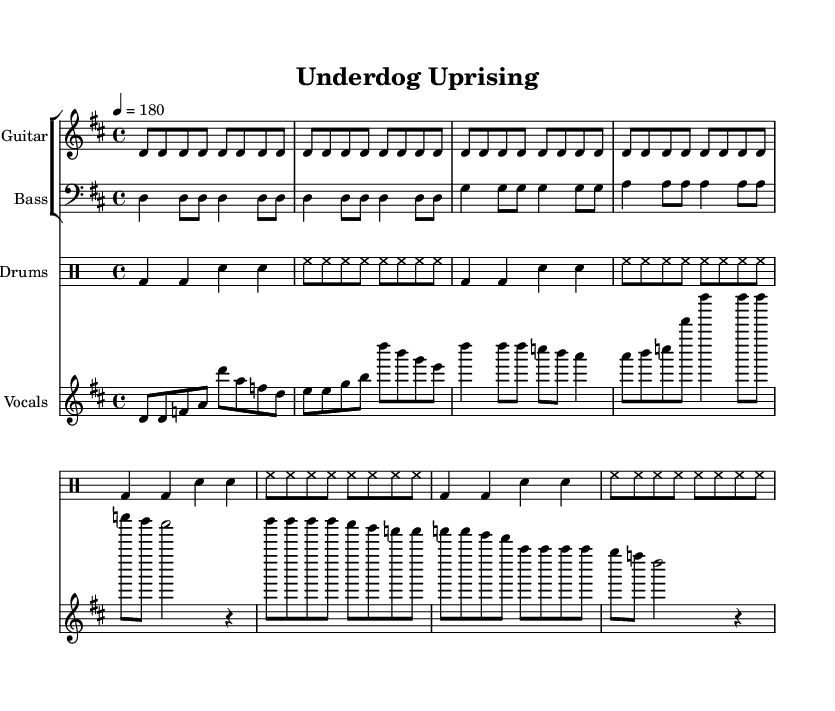What is the key signature of this music? The key signature is indicated by the sharp sign(s) at the beginning of the staff. In this piece, there are two sharps, indicating it is in D major.
Answer: D major What is the time signature of this piece? The time signature is shown at the beginning of the score, displayed as a fraction. It indicates there are four beats in a measure, with the quarter note getting one beat. This is noted as 4/4.
Answer: 4/4 What is the tempo marking of this music? The tempo is indicated at the beginning with the marking of "4 = 180," which tells the performer to play quarter notes at a speed of 180 beats per minute.
Answer: 180 How many measures are in the verse section? To determine the number of measures, we can count the number of segments in the verse melody. The verse consists of one line of music with 8 beats, equal to 4 measures since there are 2 beats per measure.
Answer: 4 What do the lyrics in the chorus section emphasize? The chorus section lyrics emphasize resilience and determination, using phrases like "come back kids" and "never say die," which evoke a fighting spirit commonly associated with underdog victories.
Answer: resilience and determination What instruments are included in this score? The score includes an electric guitar, bass guitar, drums, and vocals. Each of these instruments is represented by a staff in the score for easy identification.
Answer: Electric Guitar, Bass, Drums, Vocals How does the bridge section compare to the verse in terms of rhythm? The bridge section features a more syncopated rhythm compared to the straightforward rhythmic feel of the verse. The bridge often uses shorter notes and ties, creating a sense of urgency and intensity.
Answer: More syncopated rhythm 